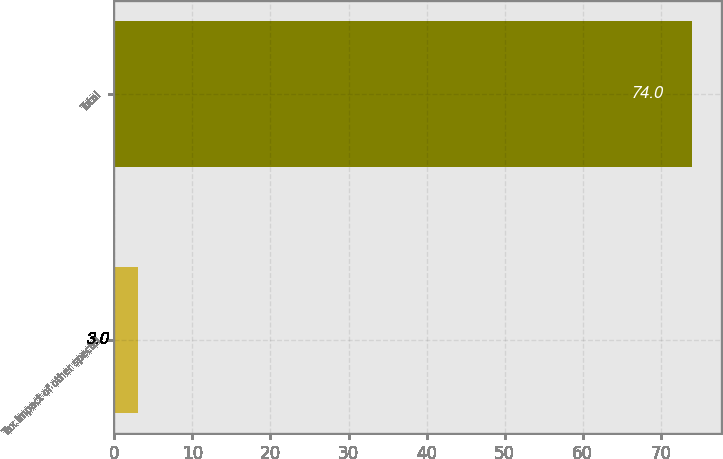Convert chart to OTSL. <chart><loc_0><loc_0><loc_500><loc_500><bar_chart><fcel>Tax impact of other special<fcel>Total<nl><fcel>3<fcel>74<nl></chart> 